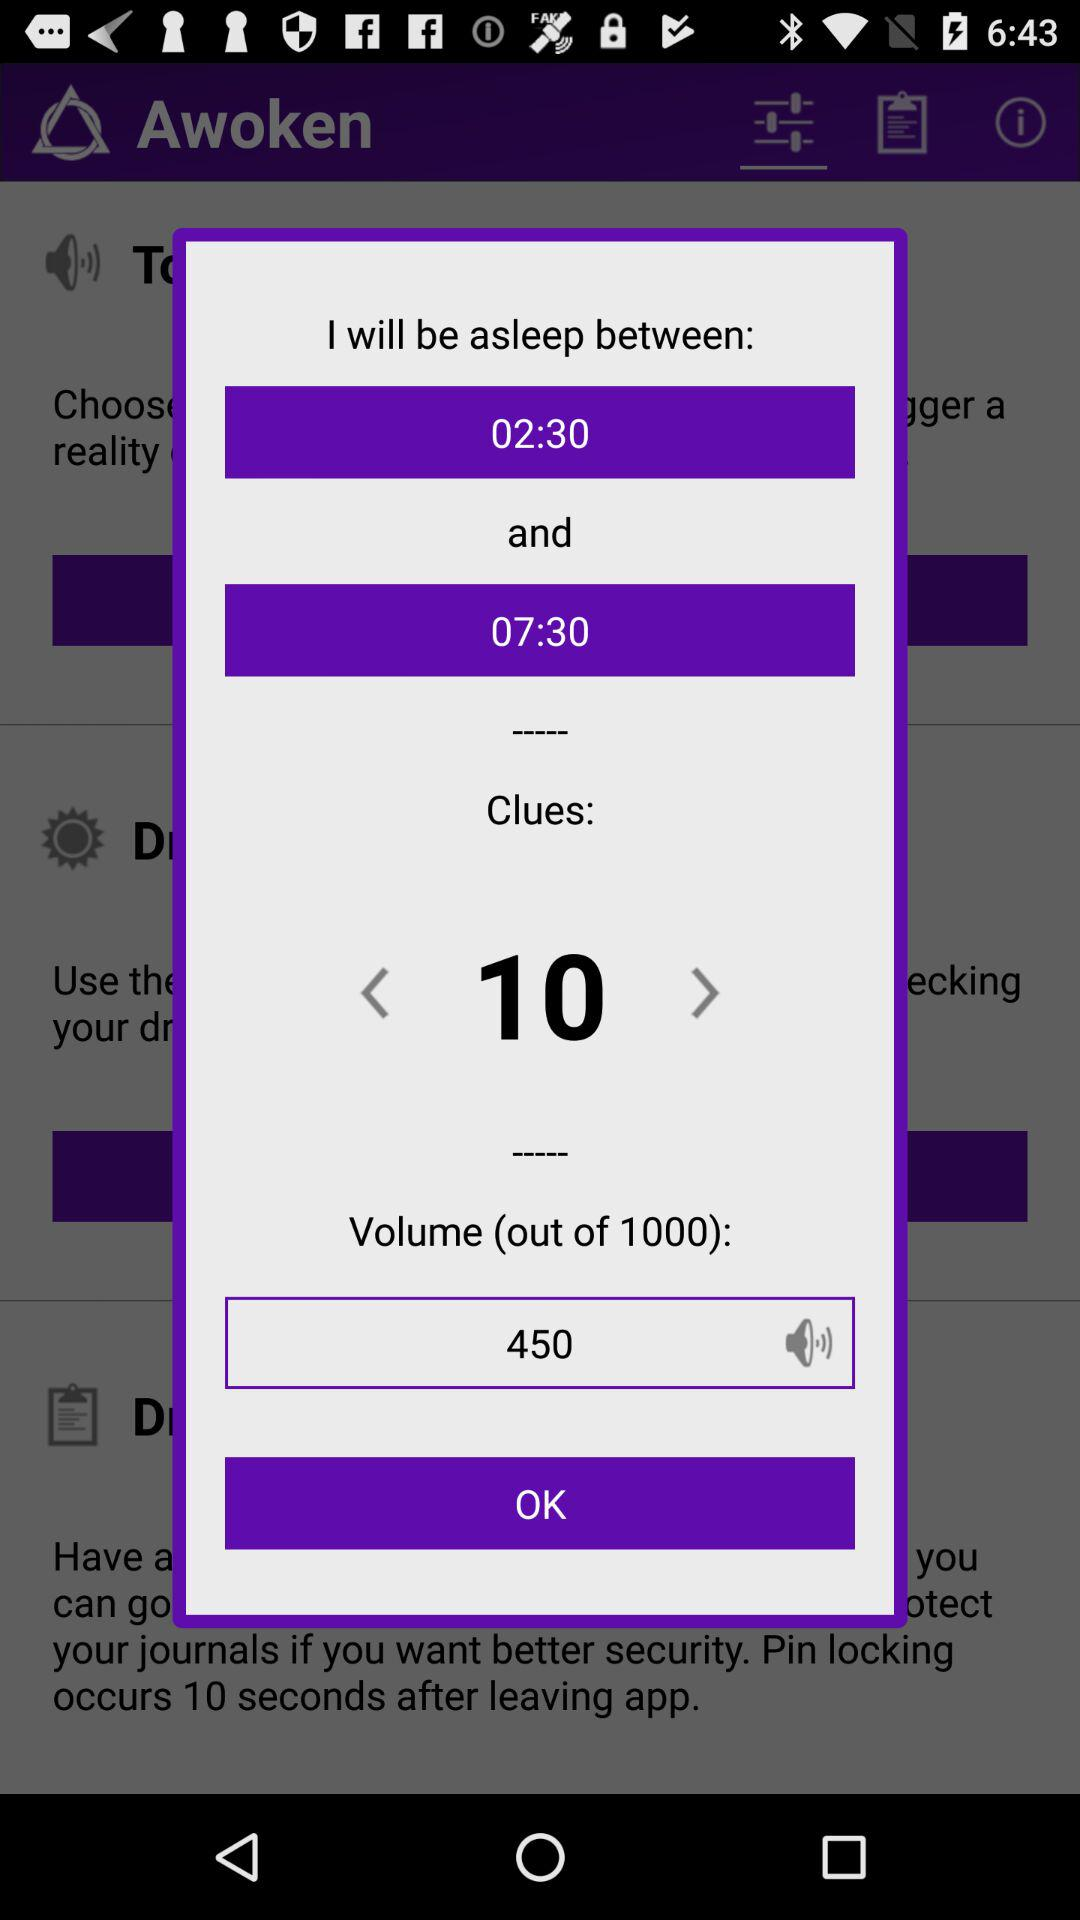What is the count of clues? The count of clues is 10. 